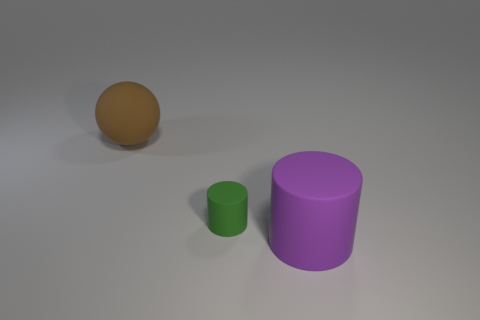Add 2 big purple metallic balls. How many objects exist? 5 Subtract all balls. How many objects are left? 2 Subtract 1 green cylinders. How many objects are left? 2 Subtract 1 cylinders. How many cylinders are left? 1 Subtract all brown cylinders. Subtract all yellow balls. How many cylinders are left? 2 Subtract all big yellow metallic spheres. Subtract all tiny things. How many objects are left? 2 Add 2 tiny matte cylinders. How many tiny matte cylinders are left? 3 Add 3 large yellow metal cylinders. How many large yellow metal cylinders exist? 3 